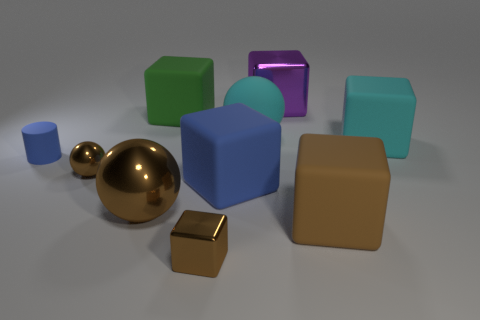The tiny shiny object that is the same color as the small metal block is what shape?
Make the answer very short. Sphere. Is the material of the large sphere on the right side of the tiny block the same as the small ball?
Your response must be concise. No. There is a purple block that is to the left of the big cyan rubber thing that is on the right side of the purple object; what is it made of?
Ensure brevity in your answer.  Metal. What number of other things are the same shape as the big blue object?
Provide a short and direct response. 5. What size is the brown shiny object right of the green object to the right of the blue matte thing that is on the left side of the green rubber object?
Ensure brevity in your answer.  Small. How many blue objects are either small shiny spheres or big rubber objects?
Ensure brevity in your answer.  1. Does the tiny brown metal object that is behind the blue block have the same shape as the purple metallic thing?
Keep it short and to the point. No. Are there more metal objects left of the cyan matte sphere than small yellow matte cylinders?
Your answer should be very brief. Yes. What number of green matte cubes have the same size as the brown metallic block?
Make the answer very short. 0. There is another shiny sphere that is the same color as the large metal sphere; what size is it?
Provide a succinct answer. Small. 